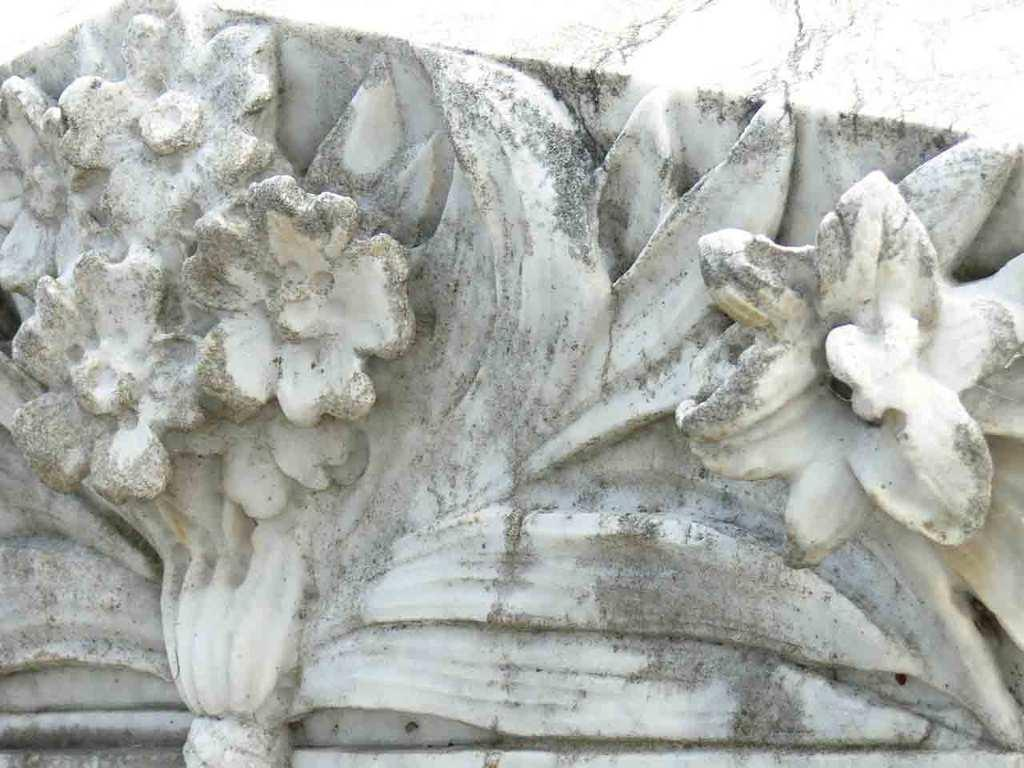What is the main subject of the image? The main subject of the image is a stone carving. Can you describe the stone carving in more detail? Unfortunately, the provided facts do not offer any additional details about the stone carving. How many babies are present in the image? There are no babies present in the image; it features a stone carving. What type of authority is depicted in the image? There is no depiction of authority in the image; it features a stone carving. 